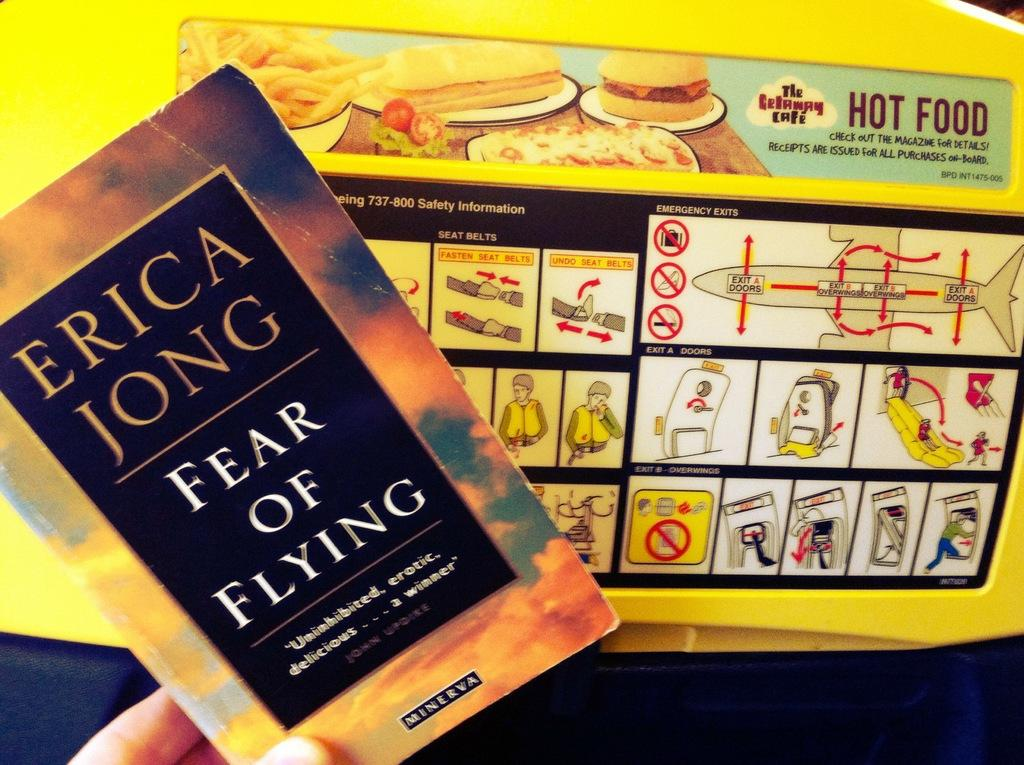<image>
Write a terse but informative summary of the picture. Person holding a book by Erica Jong named Fear of Flying. 